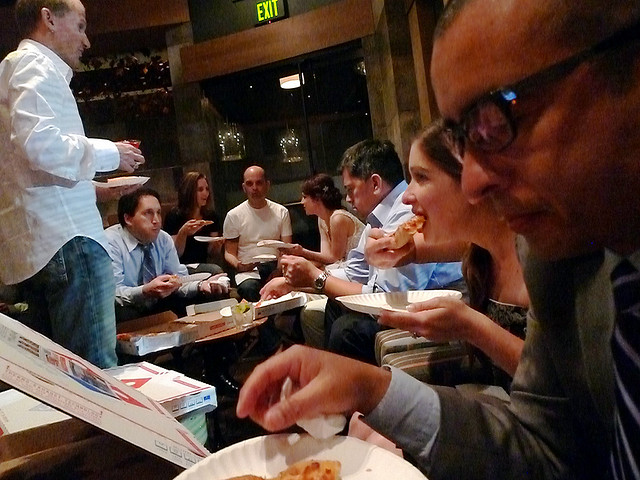Please extract the text content from this image. EXIT 